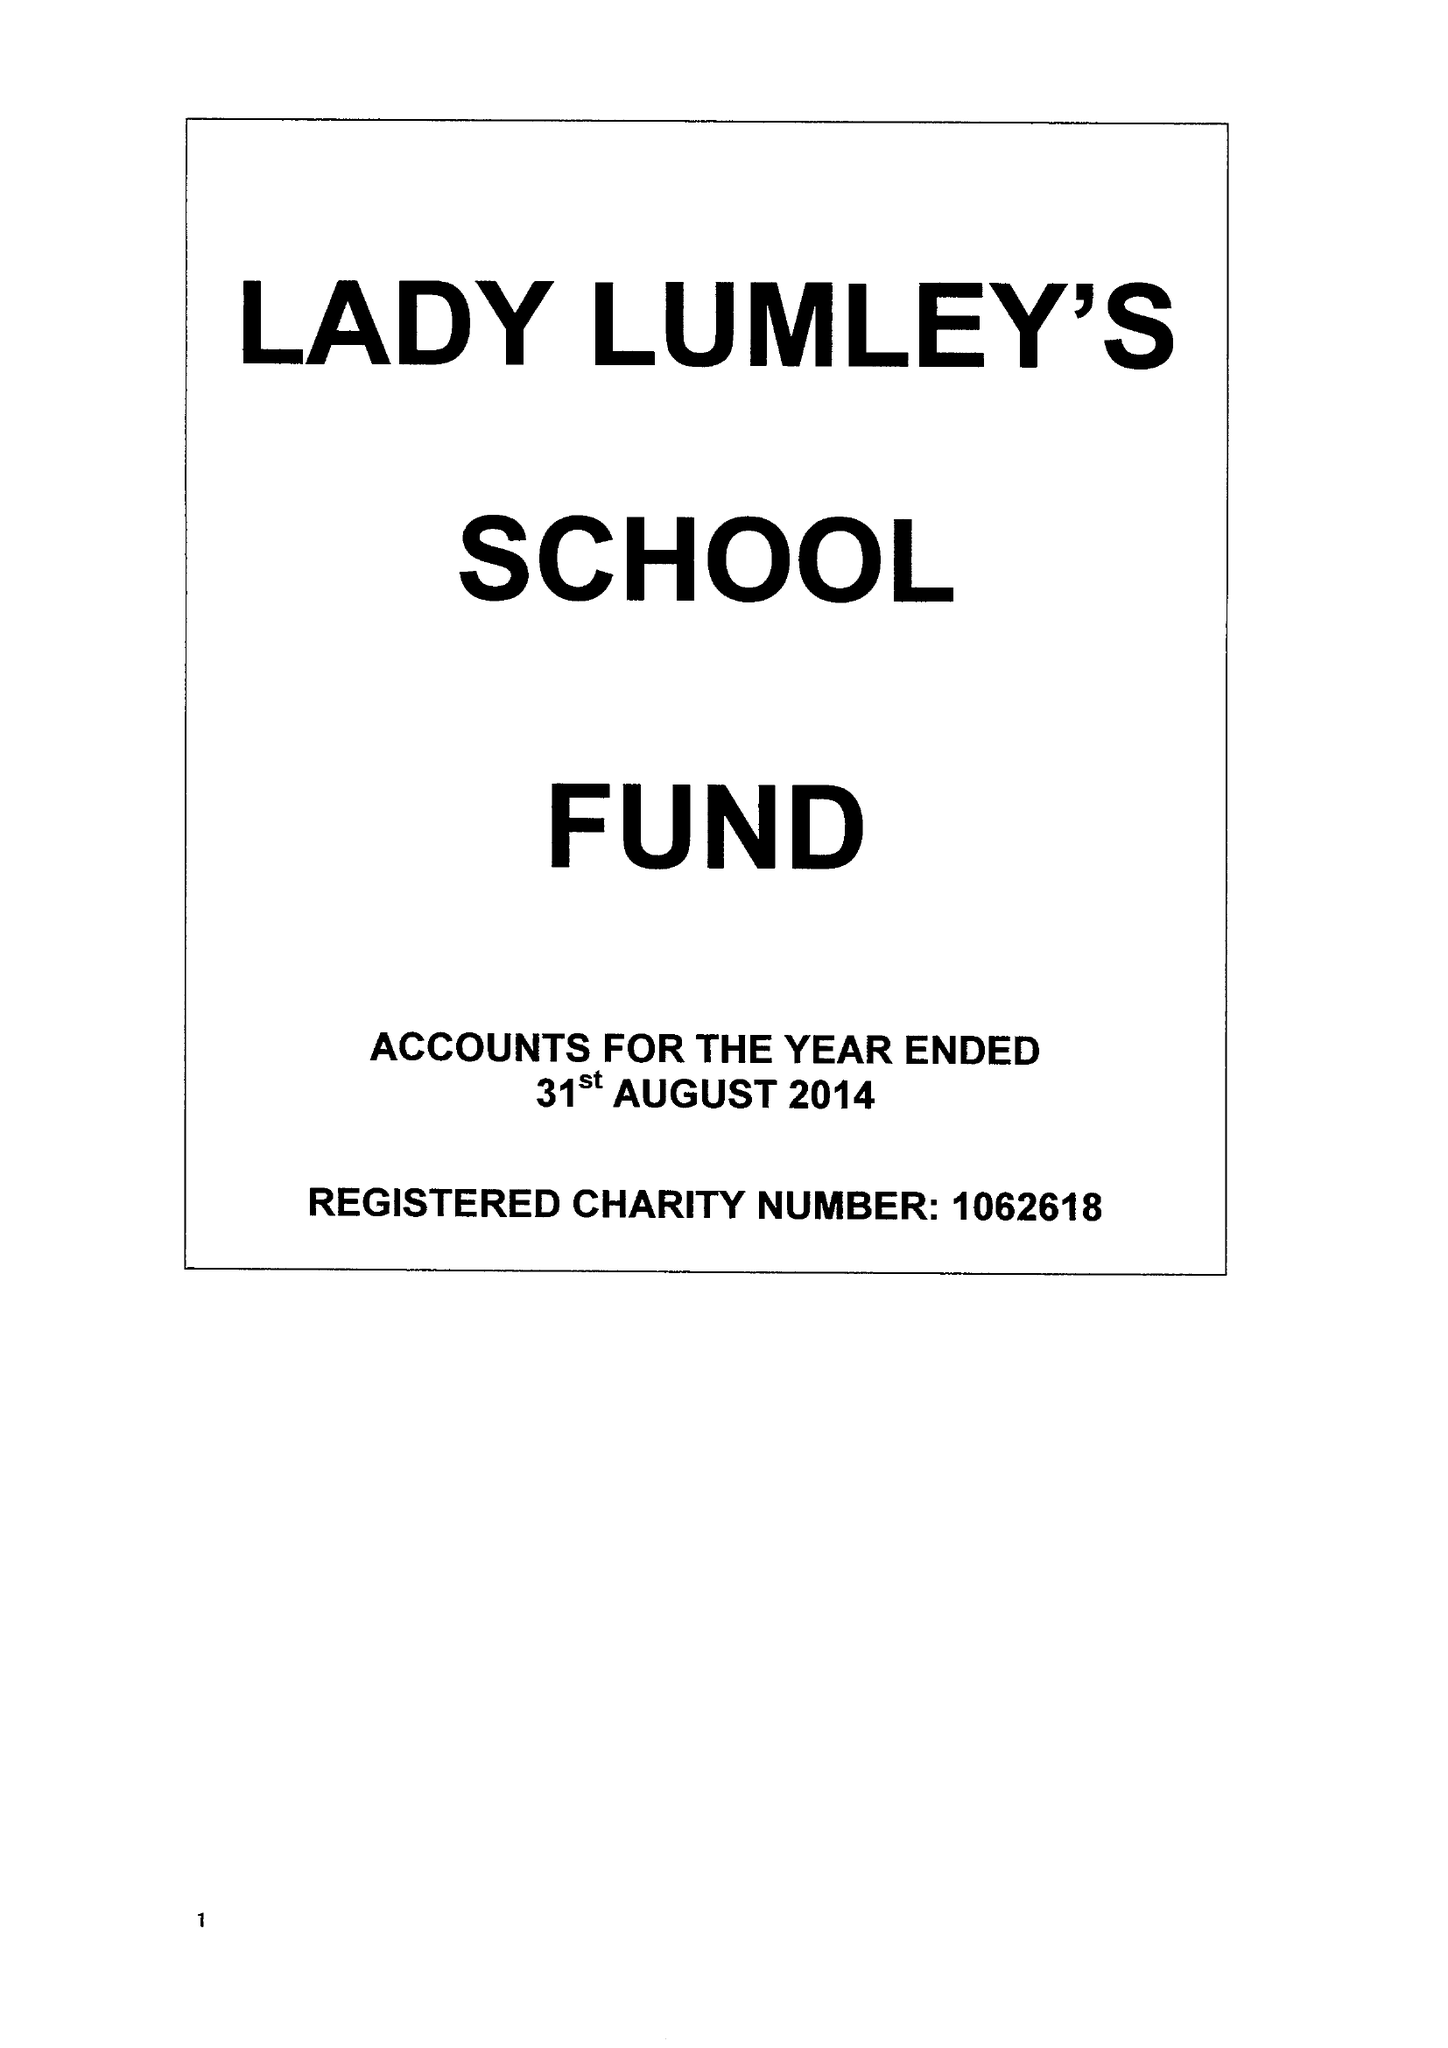What is the value for the report_date?
Answer the question using a single word or phrase. 2014-08-31 